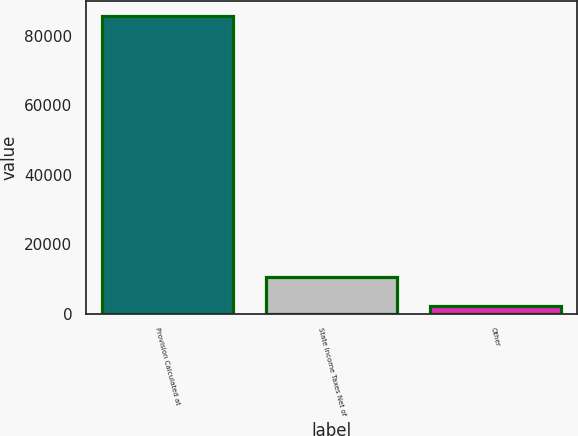Convert chart. <chart><loc_0><loc_0><loc_500><loc_500><bar_chart><fcel>Provision Calculated at<fcel>State Income Taxes Net of<fcel>Other<nl><fcel>85909<fcel>10539.4<fcel>2165<nl></chart> 